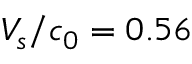<formula> <loc_0><loc_0><loc_500><loc_500>V _ { s } / c _ { 0 } = 0 . 5 6</formula> 